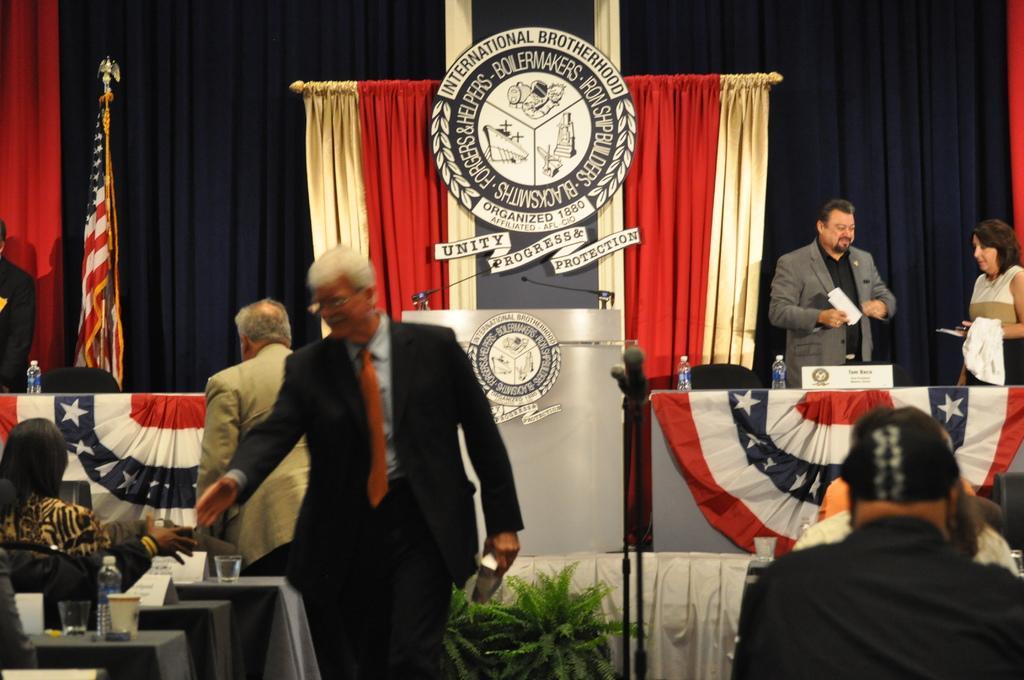How would you summarize this image in a sentence or two? In the image we can see there are people standing and other people are sitting on the chairs. On the stage there are people standing and there are water bottles on the table and behind there are flags. 